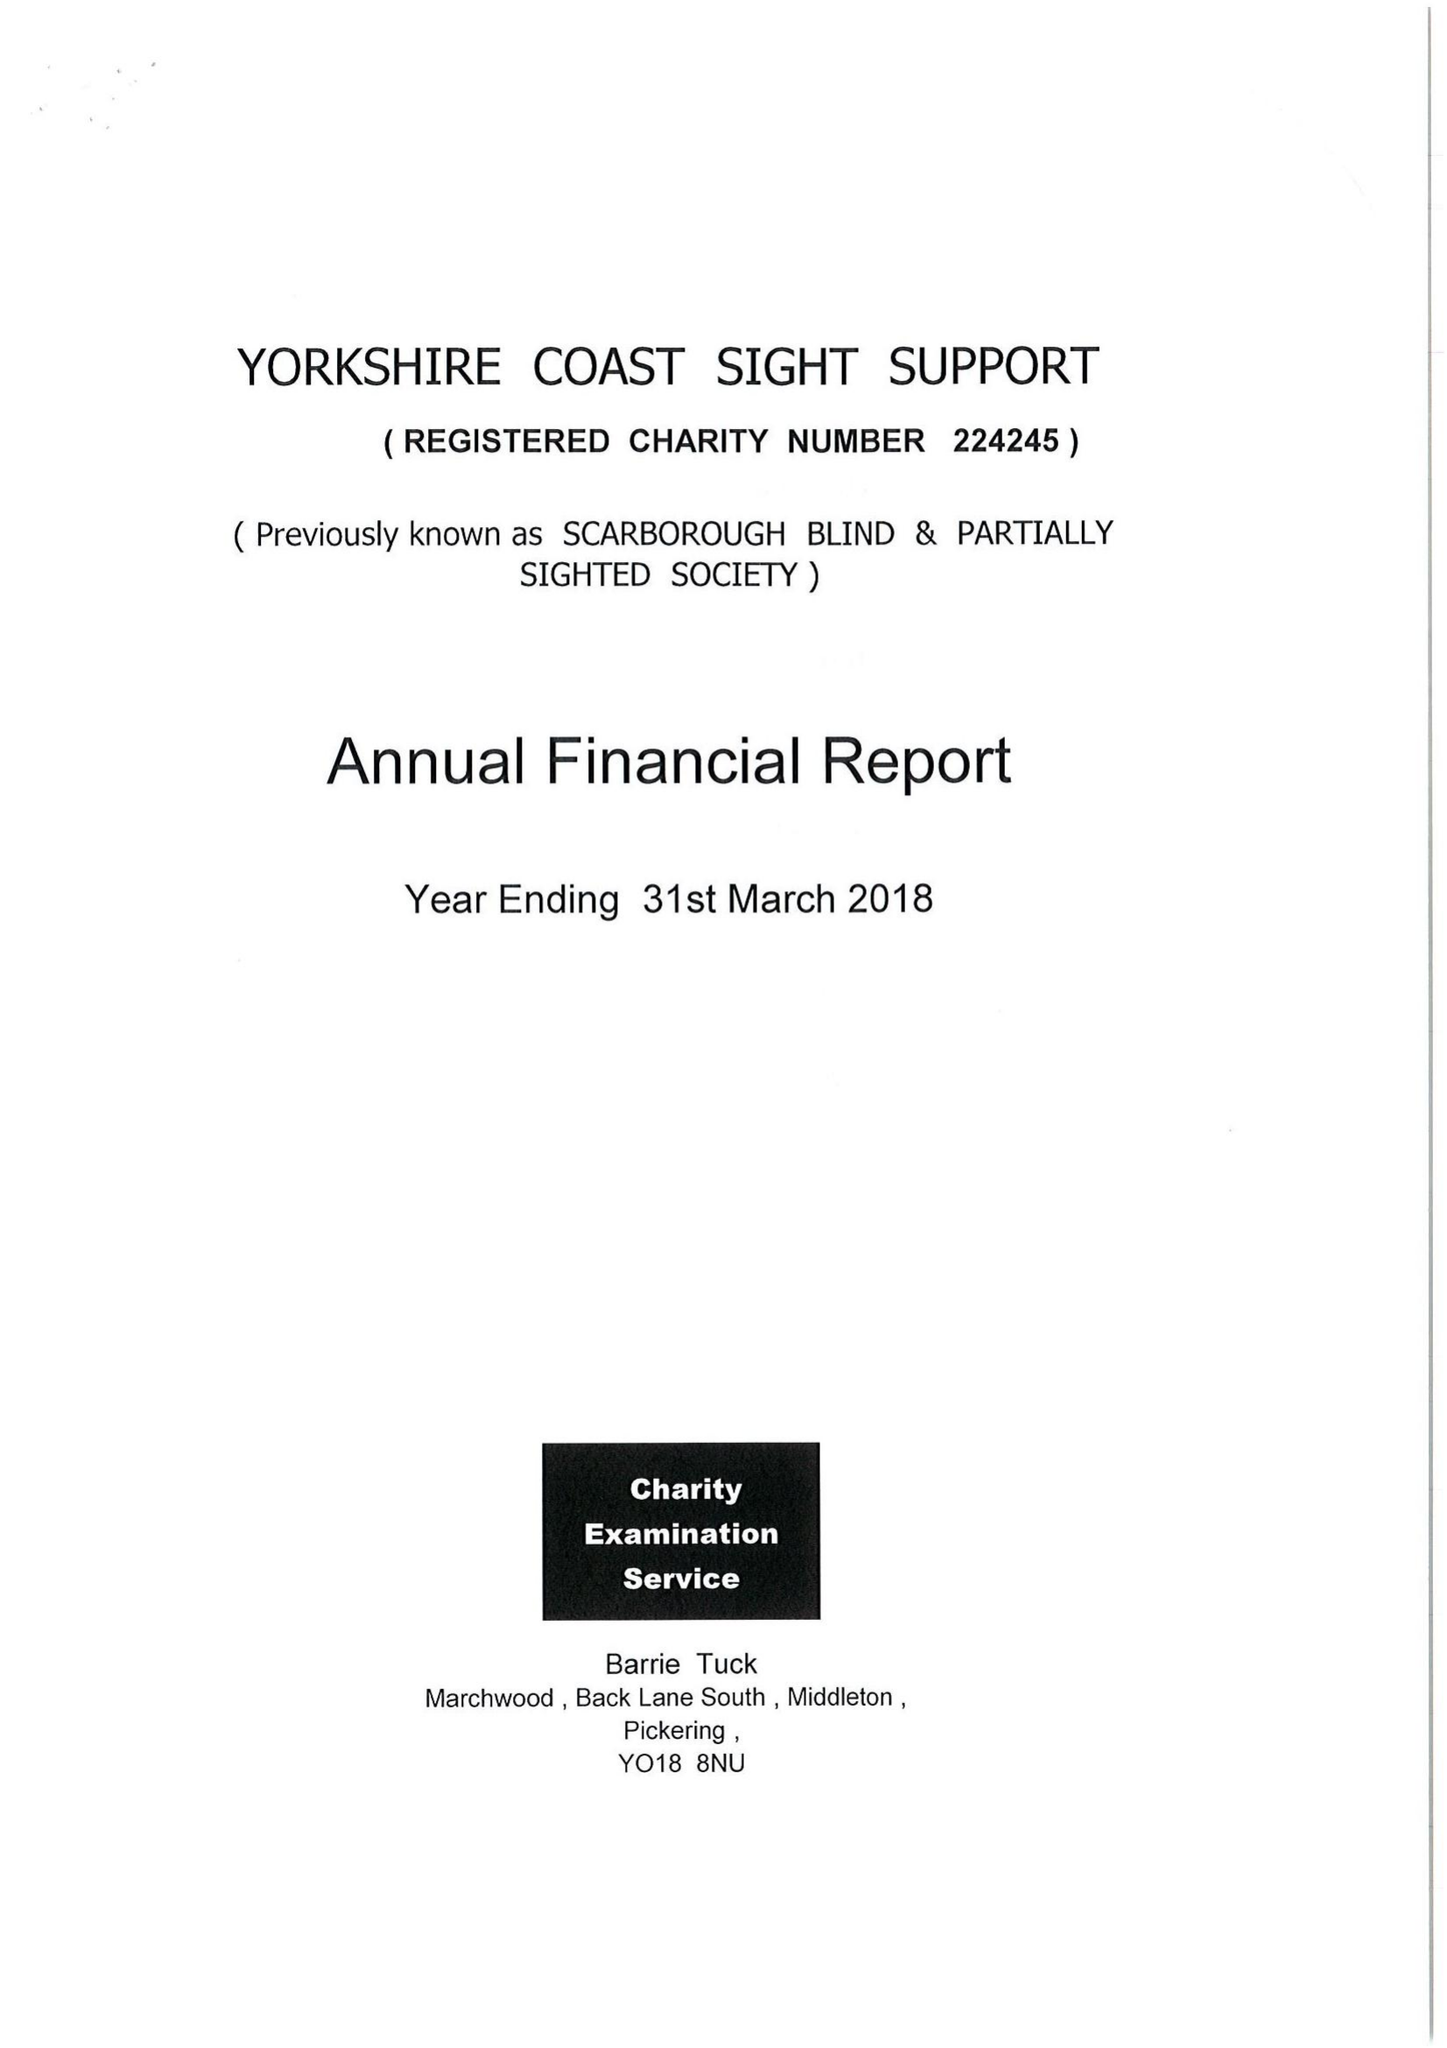What is the value for the charity_name?
Answer the question using a single word or phrase. Yorkshire Coast Sight Support 